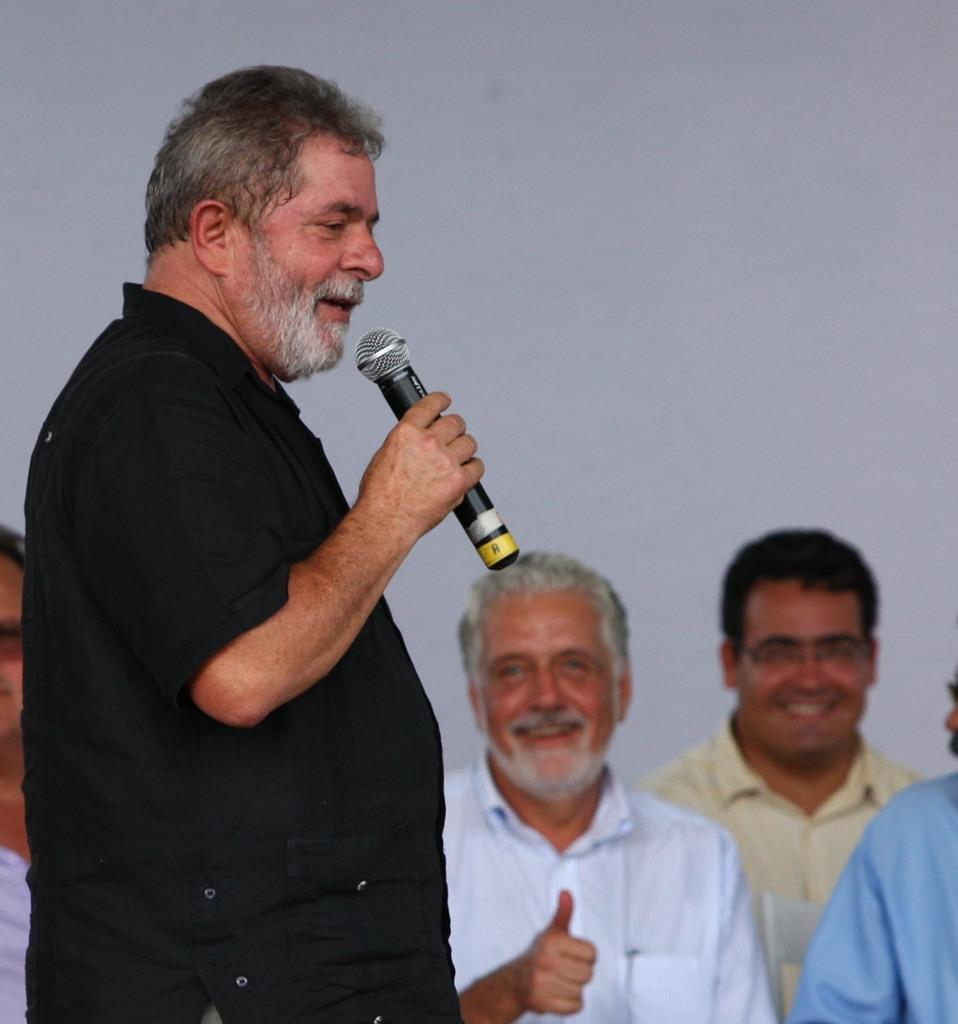What can be observed about the people in the image? There is a group of people in the image, including a person with a black shirt who is standing and talking, holding a microphone. There is also a person with a white shirt who is smiling, and a person with a yellow shirt who is also smiling. What is the person with a black shirt doing in the image? The person with a black shirt is standing and talking, holding a microphone. How are the people with white and yellow shirts feeling in the image? The person with a white shirt is smiling, and the person with a yellow shirt is also smiling. What type of work is being done in the image? There is no specific work being done in the image; it simply shows a group of people with different expressions and a person holding a microphone. Can you see any printed material in the image? There is no printed material visible in the image. 